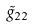Convert formula to latex. <formula><loc_0><loc_0><loc_500><loc_500>\tilde { g } _ { 2 2 }</formula> 